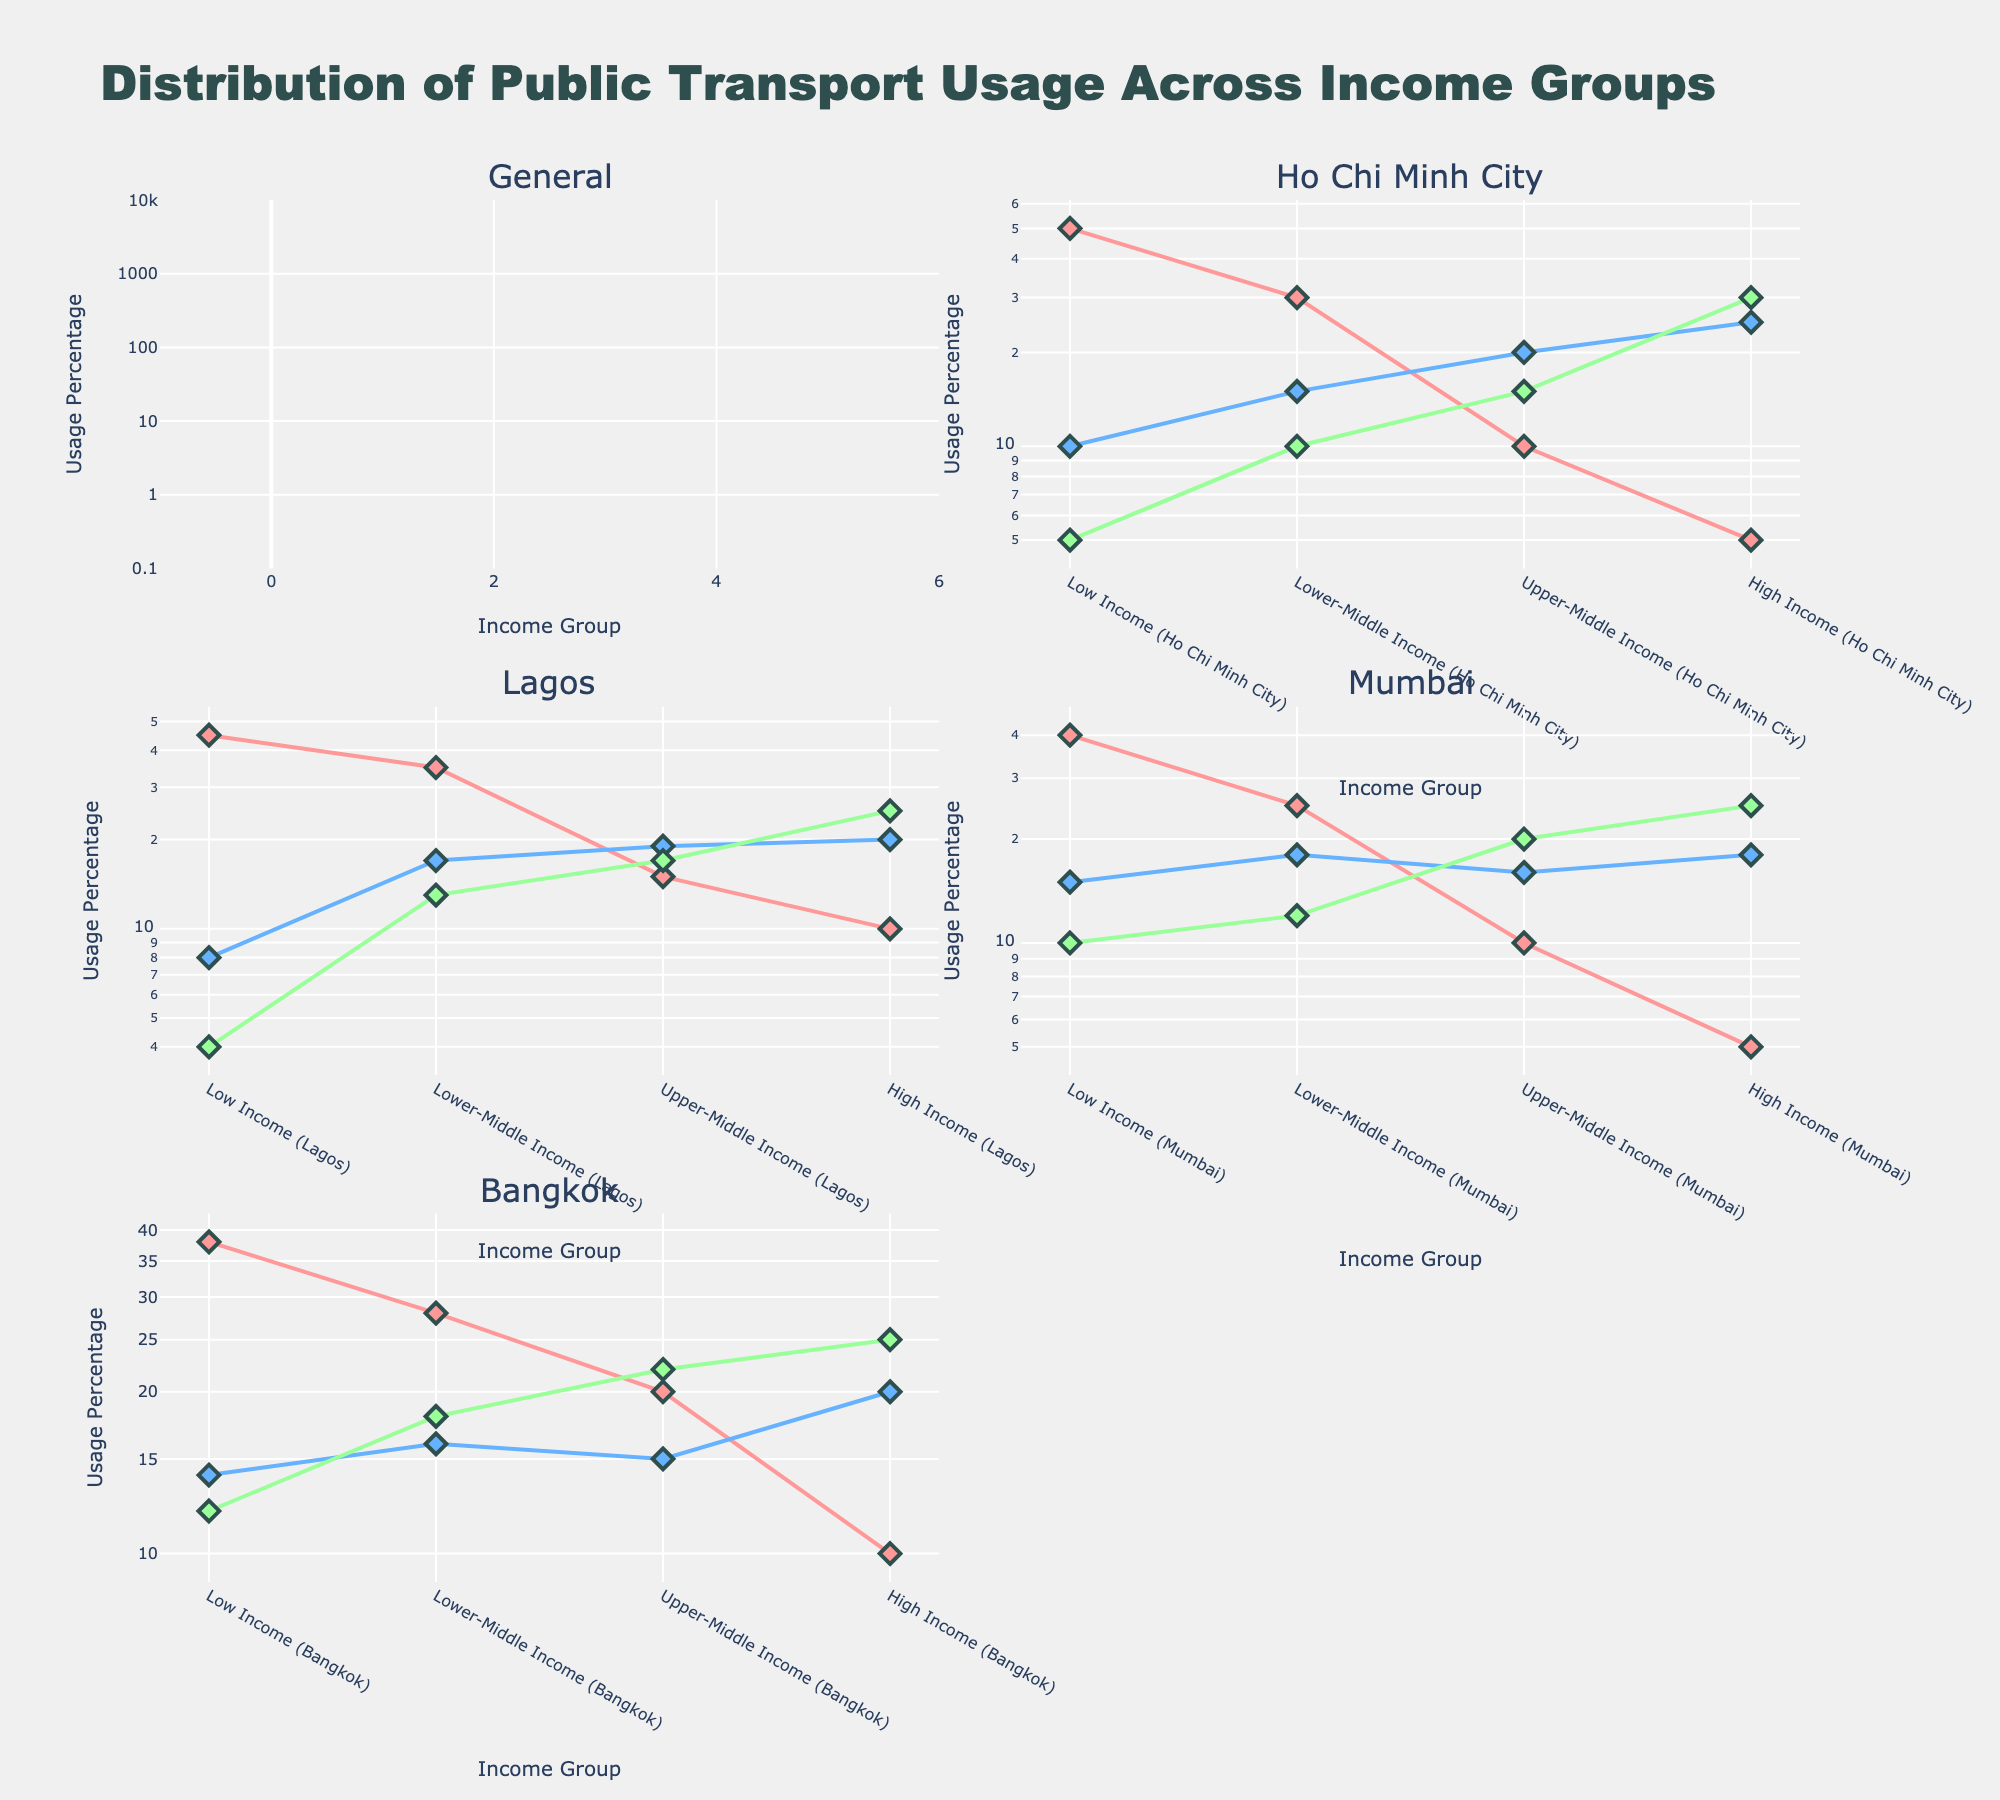What's the title of the figure? The title is located at the top of the figure and states the main topic being visualized. In this case, it reads "Distribution of Public Transport Usage Across Income Groups".
Answer: Distribution of Public Transport Usage Across Income Groups Which transport mode shows the highest usage for High Income groups in Mumbai? By inspecting the subplot titled "Mumbai" and looking at the data points for High Income groups, we can see that the Metro line (usually shown in green) has the highest usage percentage.
Answer: Metro Compare the usage of buses between Low Income groups in General and Lagos. Which is higher? By inspecting the subplots "General" and "Lagos", and looking at the values for Low Income groups, the bus usage in General is 35%, whereas in Lagos it is 45%. Therefore, Lagos has higher usage.
Answer: Lagos For Lower-Middle Income groups in Ho Chi Minh City, which transport mode has the least usage? Going to the "Ho Chi Minh City" subplot and examining the Lower-Middle Income group, the bus usage is 30%, train usage is 15%, and metro usage is 10%. The metro has the least usage.
Answer: Metro What unique pattern do we see in High-Income groups' public transport usage across all cities? By comparing the High-Income usage percentages across all subplots, a pattern emerges showing that metro usage is consistently the highest, followed by the train, and buses are the least used.
Answer: Metro highest, Train middle, Bus least Which city has the steepest decrease in bus usage from Low Income to High Income groups? By inspecting the slopes and log scales for bus usage across all subplots, it's evident that Ho Chi Minh City shows the steepest decrease where usage drops from 50% in Low Income to 5% in High Income.
Answer: Ho Chi Minh City Is the bus usage in Lagos for Low Income groups closer to the train or metro usage for the same group in the same city? Looking at Lagos Low Income group, bus usage is 45%, train usage is 8%, and metro usage is 4%. The bus usage is closer to the train usage.
Answer: Train Which city shows a more balanced distribution of usage across all modes for High Income groups? Inspecting the subplots for the High Income groups and comparing the distributions, Mumbai shows the most balanced with bus at 5%, train at 18%, and metro at 25%, compared to other cities.
Answer: Mumbai What's the general trend of metro usage across income groups for all cities? Reviewing the plots, we see a general increase in metro usage as we move from Low Income to High Income groups in all cities.
Answer: Increases 